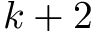Convert formula to latex. <formula><loc_0><loc_0><loc_500><loc_500>k + 2</formula> 